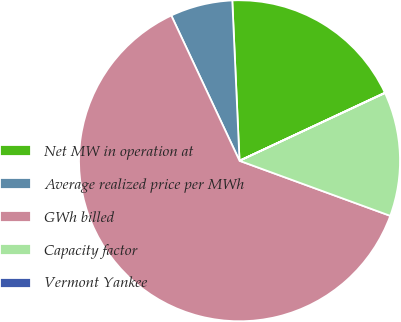Convert chart. <chart><loc_0><loc_0><loc_500><loc_500><pie_chart><fcel>Net MW in operation at<fcel>Average realized price per MWh<fcel>GWh billed<fcel>Capacity factor<fcel>Vermont Yankee<nl><fcel>18.75%<fcel>6.27%<fcel>62.43%<fcel>12.51%<fcel>0.03%<nl></chart> 